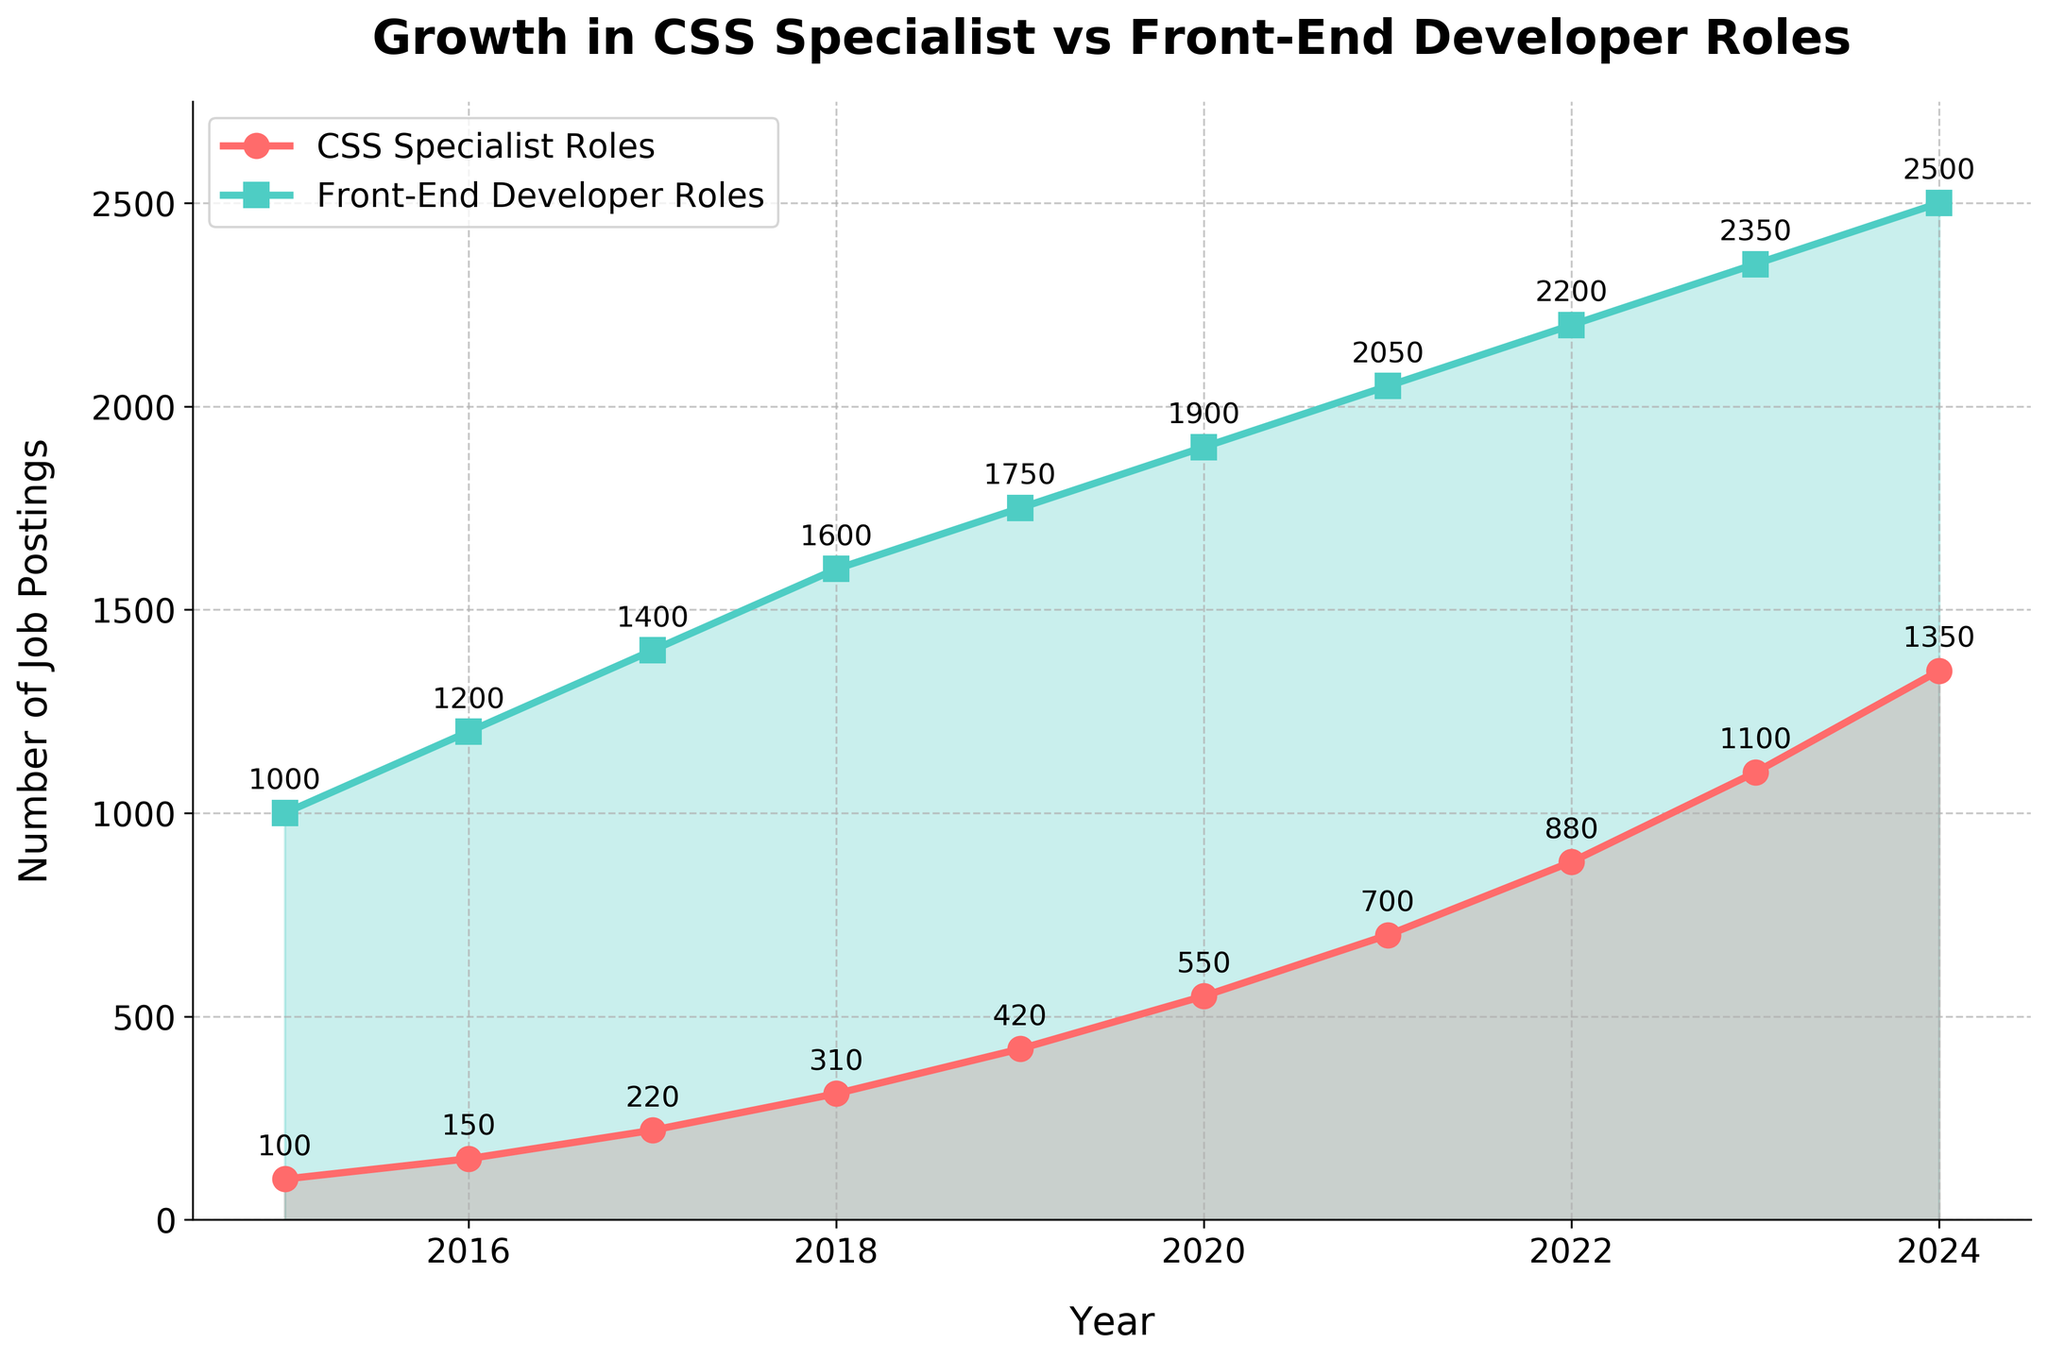What's the trend in job postings for CSS Specialist Roles from 2015 to 2024? The trend shows a steady increase in the number of job postings for CSS Specialist Roles from 2015 to 2024. Each year, the job postings increase consistently. By looking at the points marked on the line and the overall slope, we can see that the numbers rise sharply.
Answer: Steadily increasing Which year had the highest number of job postings for Front-End Developer Roles? To find the highest, observe the highest point on the line representing Front-End Developer Roles. The last point of the line in 2024 reaches the maximum value.
Answer: 2024 By how much did job postings for CSS Specialist Roles increase from 2015 to 2020? Subtract the number of postings in 2015 from the number in 2020. From 100 postings in 2015 to 550 postings in 2020, the increase is calculated as 550 - 100.
Answer: 450 How do the growth rates of CSS Specialist Roles and Front-End Developer Roles compare between 2015 and 2020? Calculate the percentage increase for both roles. For CSS Specialist Roles: ((550-100)/100)*100 = 450%. For Front-End Developer Roles: ((1900-1000)/1000)*100 = 90%. The CSS Specialist Roles have a much higher growth rate compared to Front-End Developer Roles.
Answer: CSS Specialist Roles grew faster Which role had more job postings in 2018, and by how much? Compare the values for both roles in 2018. CSS Specialist Roles had 310 postings, while Front-End Developer Roles had 1600. The difference is 1600 - 310.
Answer: Front-End Developer Roles by 1290 What is the average number of job postings for CSS Specialist Roles from 2015 to 2020? Sum the job postings from 2015 to 2020 and divide by the number of years. The sum is 100 + 150 + 220 + 310 + 420 + 550 = 1750. The average is 1750/6.
Answer: 291.67 In 2023, how many more job postings were there for Front-End Developer Roles compared to CSS Specialist Roles? Subtract the number of CSS Specialist Roles from Front-End Developer Roles in 2023. For 2023, it's 2350 (Front-End Developer Roles) - 1100 (CSS Specialist Roles).
Answer: 1250 What's the color used for the line representing CSS Specialist Roles in the chart? This can be determined by directly looking at the color used for the line in the chart. The line for CSS Specialist Roles is colored in red.
Answer: Red Based on the visual attributes, which line appears to have a steeper slope, indicating higher growth over time? A steeper slope indicates a faster increase over time. By examining the angles of the lines, the line for CSS Specialist Roles shows a steeper slope compared to Front-End Developer Roles.
Answer: CSS Specialist Roles Between which consecutive years did CSS Specialist Roles see the highest absolute increase in job postings? Calculate the difference in job postings between each consecutive year for CSS Specialist Roles and identify the largest difference. The difference between 2023 (1100) and 2024 (1350) is the highest with 1350 - 1100.
Answer: 2023 to 2024 